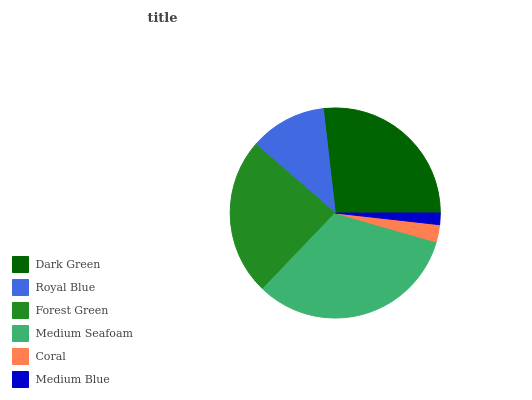Is Medium Blue the minimum?
Answer yes or no. Yes. Is Medium Seafoam the maximum?
Answer yes or no. Yes. Is Royal Blue the minimum?
Answer yes or no. No. Is Royal Blue the maximum?
Answer yes or no. No. Is Dark Green greater than Royal Blue?
Answer yes or no. Yes. Is Royal Blue less than Dark Green?
Answer yes or no. Yes. Is Royal Blue greater than Dark Green?
Answer yes or no. No. Is Dark Green less than Royal Blue?
Answer yes or no. No. Is Forest Green the high median?
Answer yes or no. Yes. Is Royal Blue the low median?
Answer yes or no. Yes. Is Coral the high median?
Answer yes or no. No. Is Forest Green the low median?
Answer yes or no. No. 